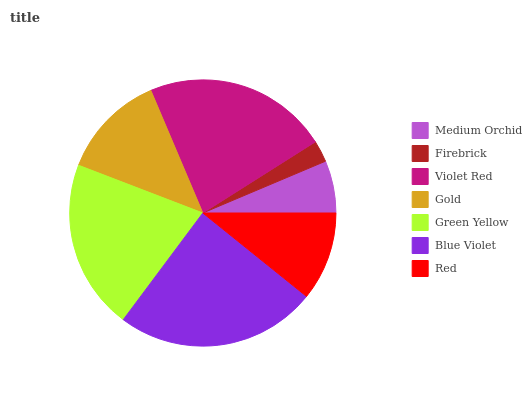Is Firebrick the minimum?
Answer yes or no. Yes. Is Blue Violet the maximum?
Answer yes or no. Yes. Is Violet Red the minimum?
Answer yes or no. No. Is Violet Red the maximum?
Answer yes or no. No. Is Violet Red greater than Firebrick?
Answer yes or no. Yes. Is Firebrick less than Violet Red?
Answer yes or no. Yes. Is Firebrick greater than Violet Red?
Answer yes or no. No. Is Violet Red less than Firebrick?
Answer yes or no. No. Is Gold the high median?
Answer yes or no. Yes. Is Gold the low median?
Answer yes or no. Yes. Is Green Yellow the high median?
Answer yes or no. No. Is Green Yellow the low median?
Answer yes or no. No. 